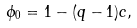Convert formula to latex. <formula><loc_0><loc_0><loc_500><loc_500>\phi _ { 0 } = 1 - ( q - 1 ) c ,</formula> 